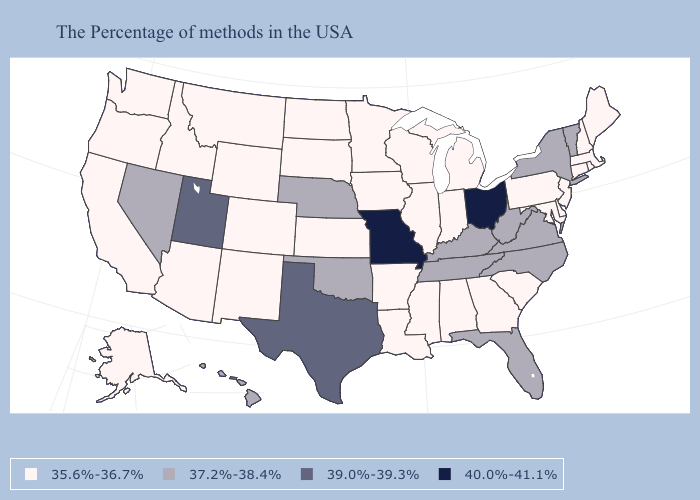Name the states that have a value in the range 35.6%-36.7%?
Write a very short answer. Maine, Massachusetts, Rhode Island, New Hampshire, Connecticut, New Jersey, Delaware, Maryland, Pennsylvania, South Carolina, Georgia, Michigan, Indiana, Alabama, Wisconsin, Illinois, Mississippi, Louisiana, Arkansas, Minnesota, Iowa, Kansas, South Dakota, North Dakota, Wyoming, Colorado, New Mexico, Montana, Arizona, Idaho, California, Washington, Oregon, Alaska. Which states have the lowest value in the Northeast?
Give a very brief answer. Maine, Massachusetts, Rhode Island, New Hampshire, Connecticut, New Jersey, Pennsylvania. Name the states that have a value in the range 37.2%-38.4%?
Keep it brief. Vermont, New York, Virginia, North Carolina, West Virginia, Florida, Kentucky, Tennessee, Nebraska, Oklahoma, Nevada, Hawaii. Is the legend a continuous bar?
Short answer required. No. Does New Mexico have the same value as Wyoming?
Answer briefly. Yes. Does Tennessee have the same value as Wisconsin?
Write a very short answer. No. Name the states that have a value in the range 39.0%-39.3%?
Keep it brief. Texas, Utah. What is the highest value in states that border Alabama?
Give a very brief answer. 37.2%-38.4%. What is the value of Tennessee?
Be succinct. 37.2%-38.4%. Does Virginia have a higher value than Kentucky?
Quick response, please. No. What is the lowest value in the MidWest?
Short answer required. 35.6%-36.7%. Does the map have missing data?
Write a very short answer. No. Does South Carolina have a lower value than Mississippi?
Answer briefly. No. What is the lowest value in states that border Georgia?
Concise answer only. 35.6%-36.7%. Which states hav the highest value in the Northeast?
Keep it brief. Vermont, New York. 